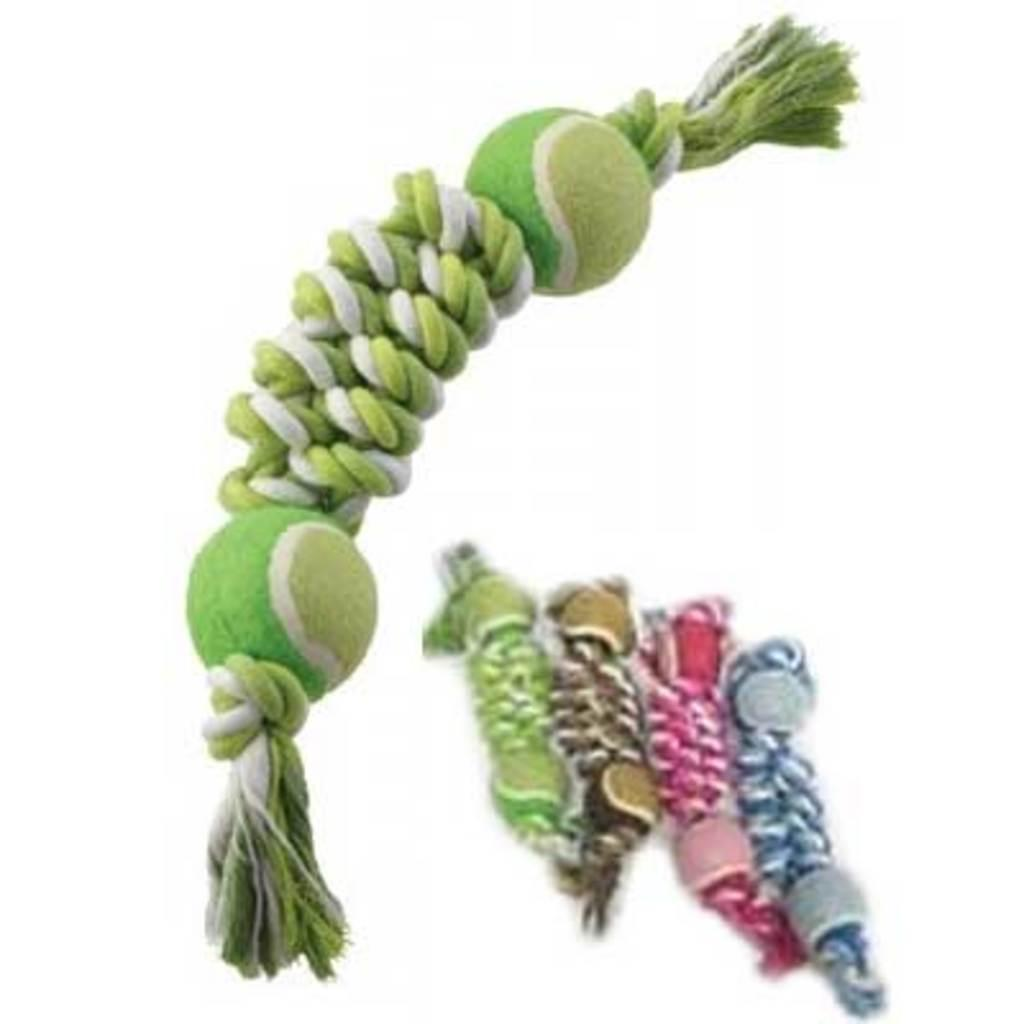What objects are present in the image? There are balls in the image. How are the balls connected or arranged? The balls are tied with ropes. What type of part is visible on the cat in the image? There is no cat present in the image, and therefore no parts can be observed. 